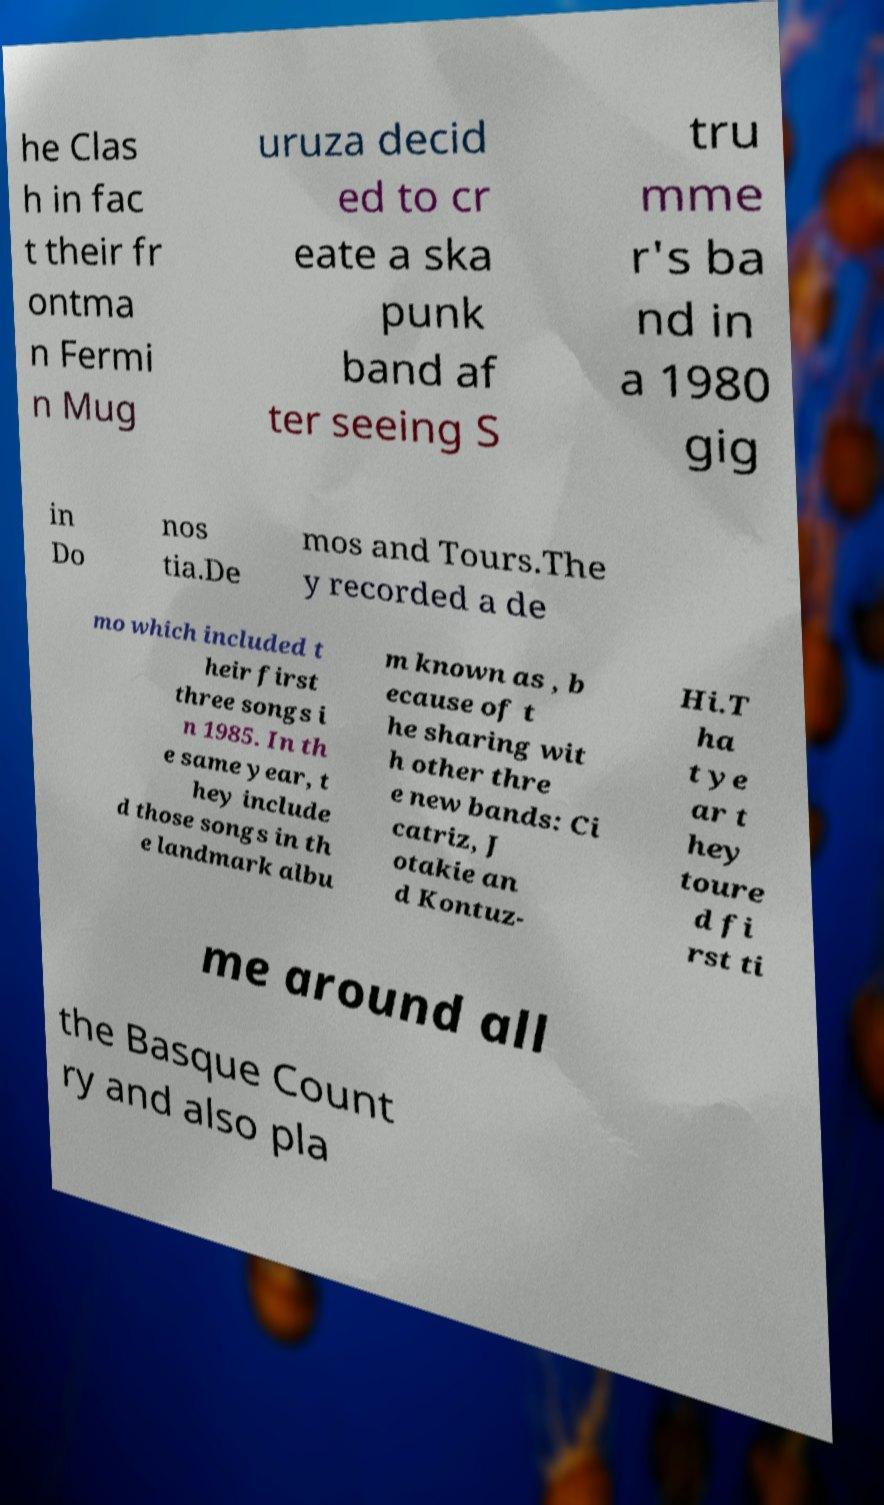What messages or text are displayed in this image? I need them in a readable, typed format. he Clas h in fac t their fr ontma n Fermi n Mug uruza decid ed to cr eate a ska punk band af ter seeing S tru mme r's ba nd in a 1980 gig in Do nos tia.De mos and Tours.The y recorded a de mo which included t heir first three songs i n 1985. In th e same year, t hey include d those songs in th e landmark albu m known as , b ecause of t he sharing wit h other thre e new bands: Ci catriz, J otakie an d Kontuz- Hi.T ha t ye ar t hey toure d fi rst ti me around all the Basque Count ry and also pla 